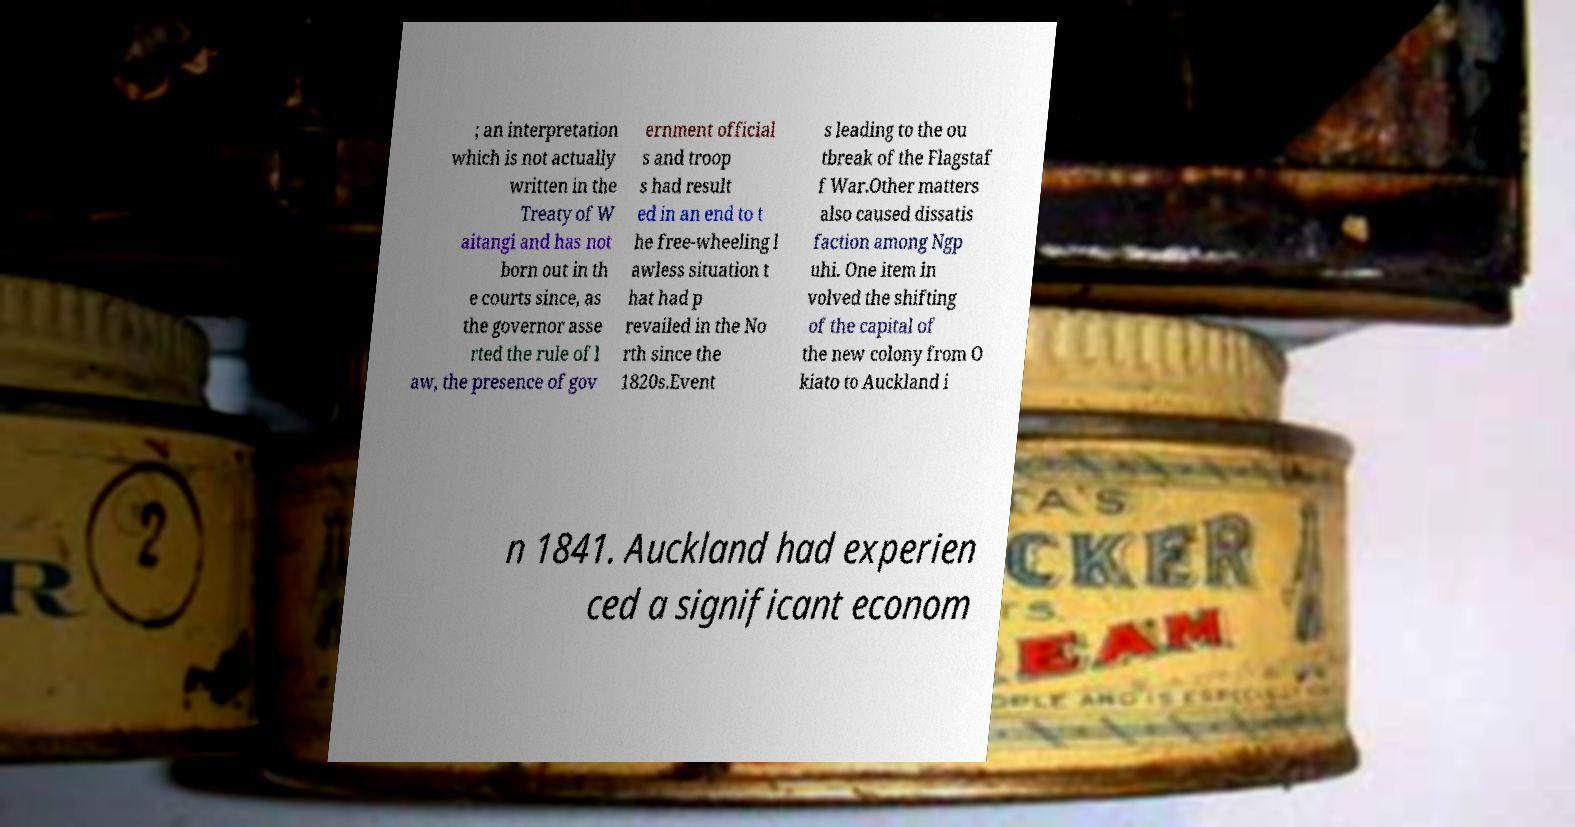Could you extract and type out the text from this image? ; an interpretation which is not actually written in the Treaty of W aitangi and has not born out in th e courts since, as the governor asse rted the rule of l aw, the presence of gov ernment official s and troop s had result ed in an end to t he free-wheeling l awless situation t hat had p revailed in the No rth since the 1820s.Event s leading to the ou tbreak of the Flagstaf f War.Other matters also caused dissatis faction among Ngp uhi. One item in volved the shifting of the capital of the new colony from O kiato to Auckland i n 1841. Auckland had experien ced a significant econom 